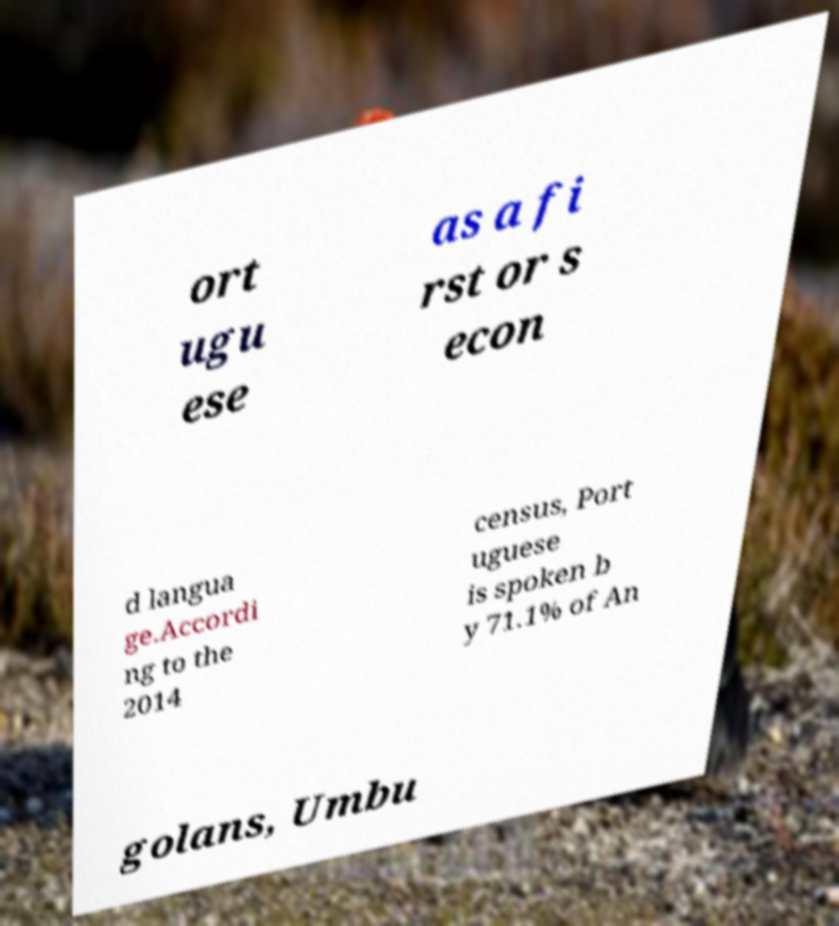I need the written content from this picture converted into text. Can you do that? ort ugu ese as a fi rst or s econ d langua ge.Accordi ng to the 2014 census, Port uguese is spoken b y 71.1% of An golans, Umbu 